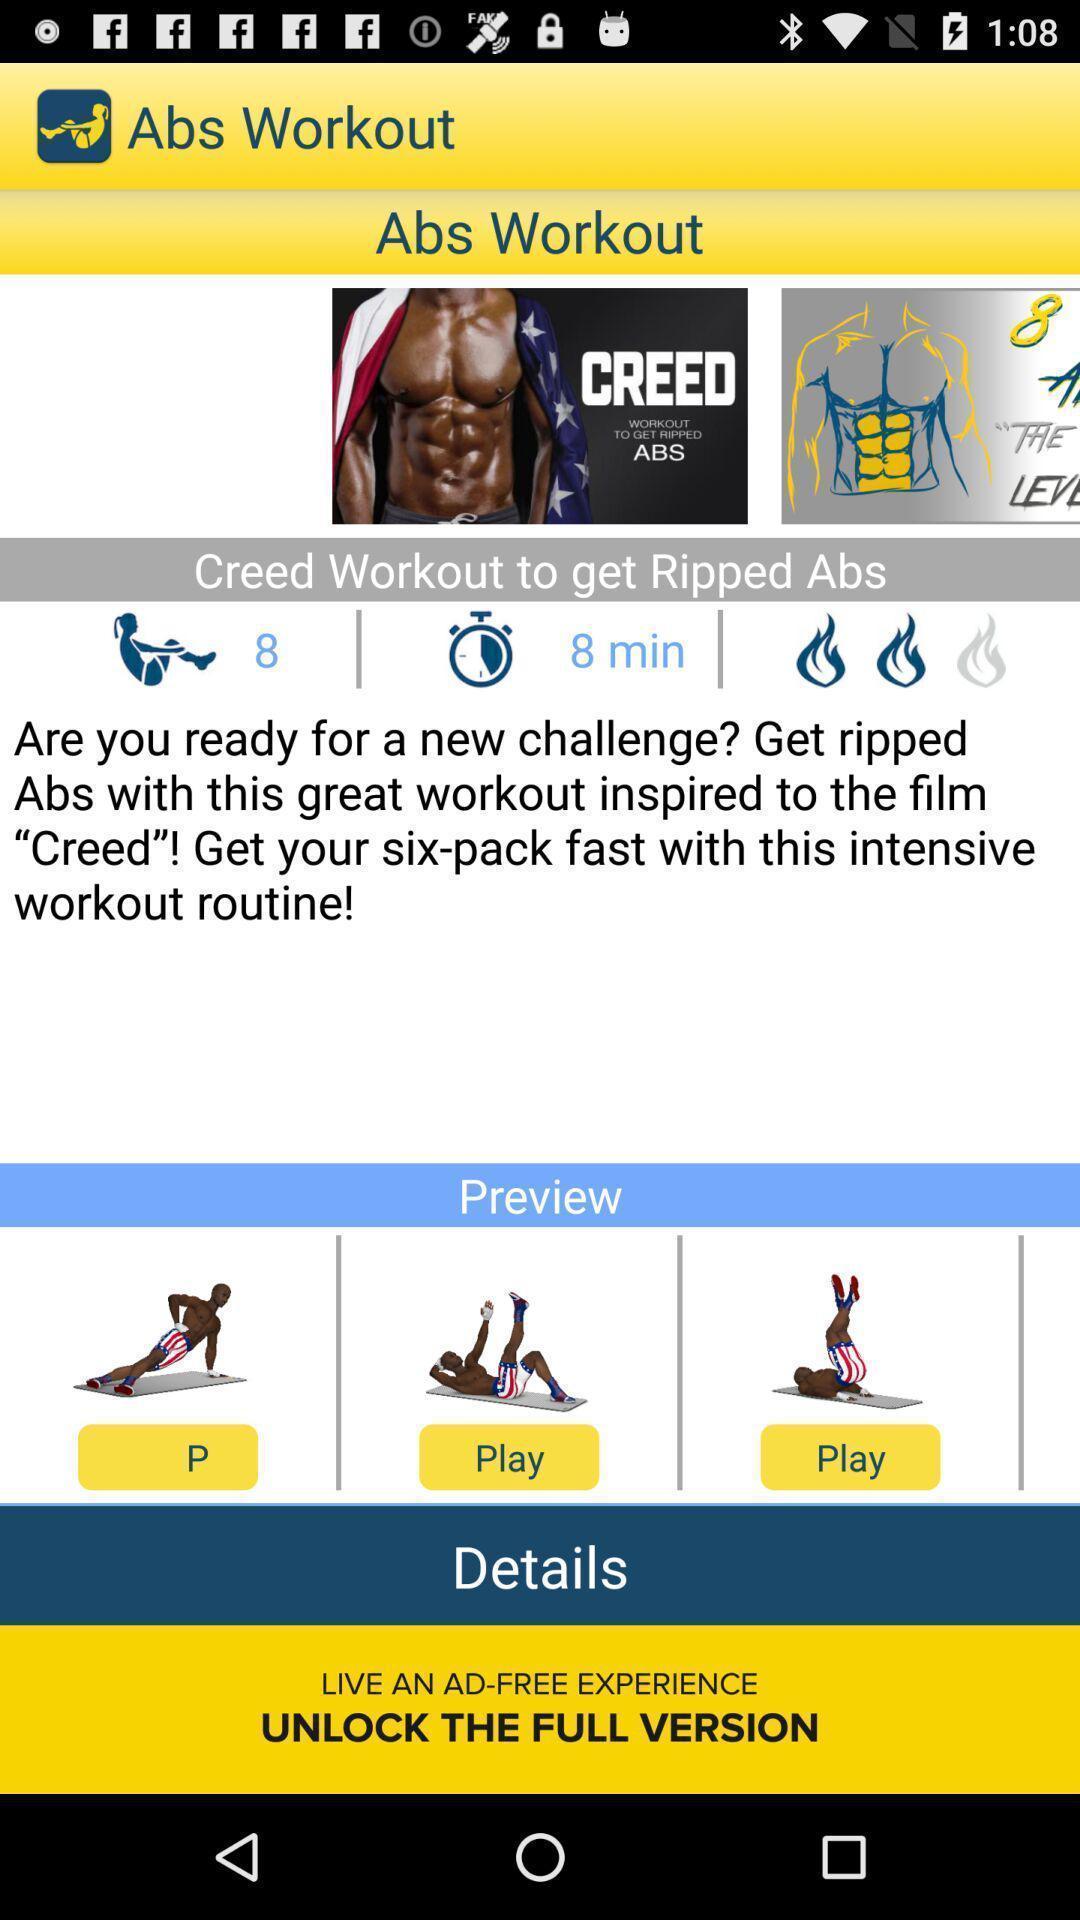Give me a summary of this screen capture. Page displaying workout details in fitness app. 